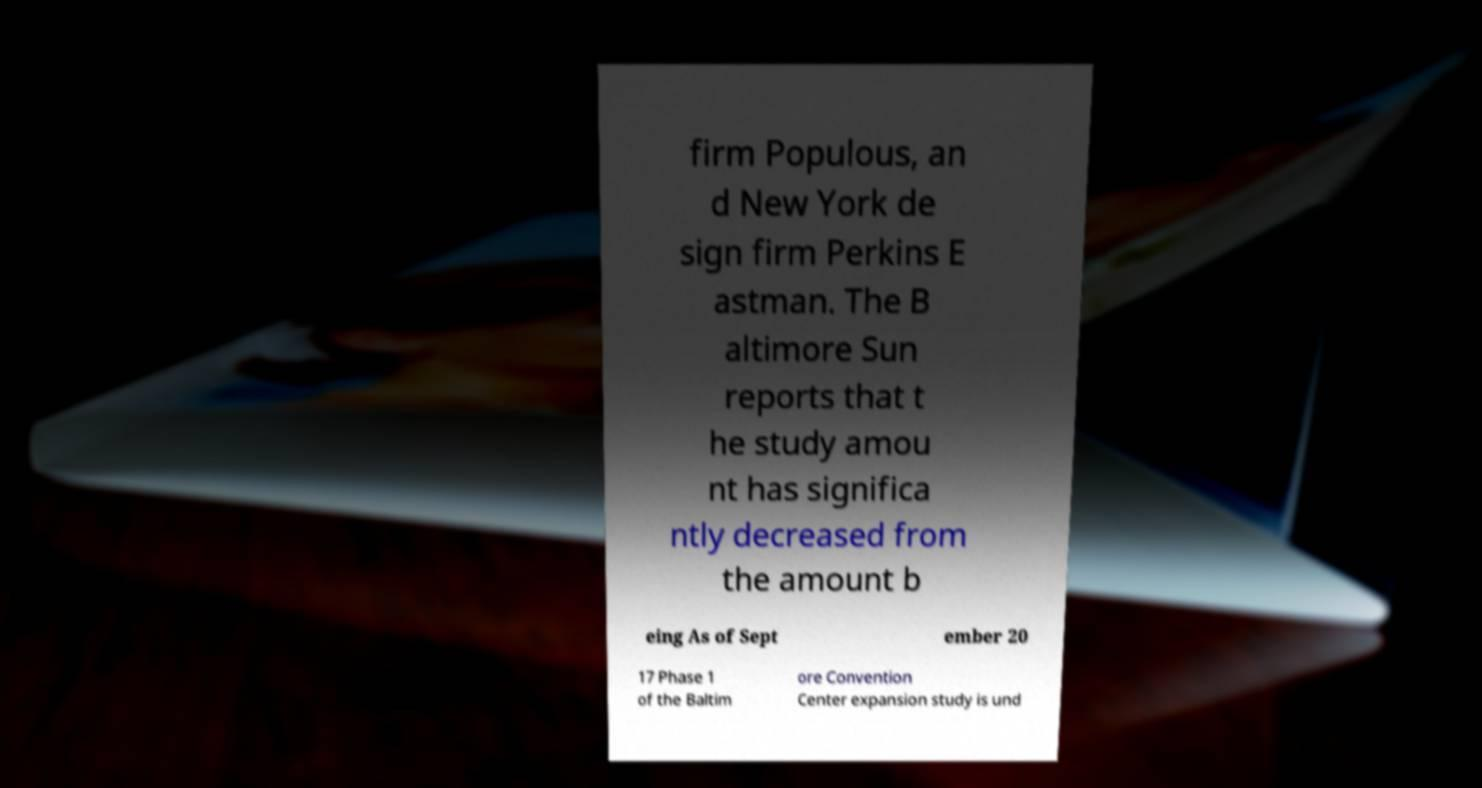Please read and relay the text visible in this image. What does it say? firm Populous, an d New York de sign firm Perkins E astman. The B altimore Sun reports that t he study amou nt has significa ntly decreased from the amount b eing As of Sept ember 20 17 Phase 1 of the Baltim ore Convention Center expansion study is und 